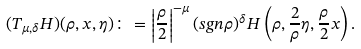Convert formula to latex. <formula><loc_0><loc_0><loc_500><loc_500>( T _ { \mu , \delta } H ) ( \rho , x , \eta ) \colon = \left | \frac { \rho } { 2 } \right | ^ { - \mu } ( { s g n } \rho ) ^ { \delta } H \left ( \rho , \frac { 2 } { \rho } \eta , \frac { \rho } { 2 } x \right ) .</formula> 